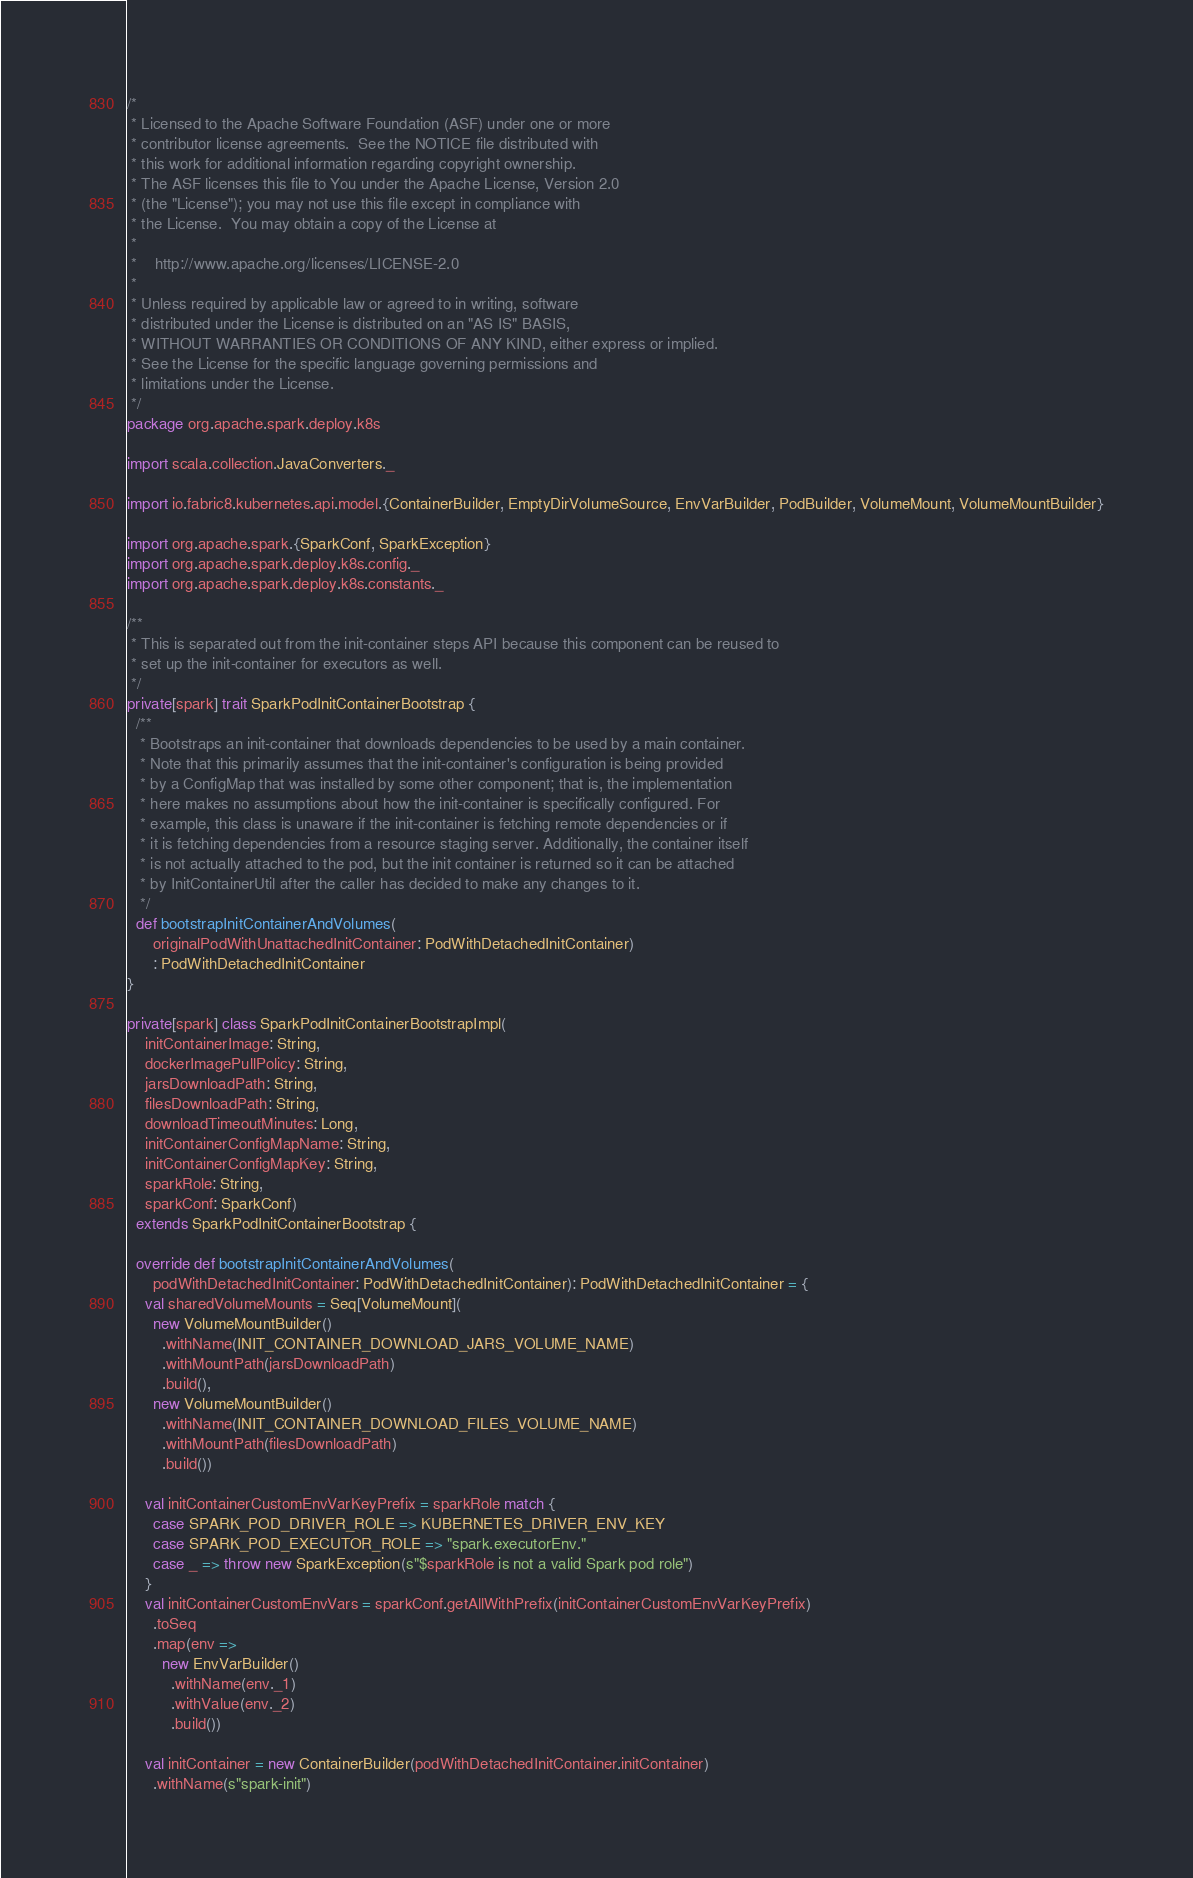Convert code to text. <code><loc_0><loc_0><loc_500><loc_500><_Scala_>/*
 * Licensed to the Apache Software Foundation (ASF) under one or more
 * contributor license agreements.  See the NOTICE file distributed with
 * this work for additional information regarding copyright ownership.
 * The ASF licenses this file to You under the Apache License, Version 2.0
 * (the "License"); you may not use this file except in compliance with
 * the License.  You may obtain a copy of the License at
 *
 *    http://www.apache.org/licenses/LICENSE-2.0
 *
 * Unless required by applicable law or agreed to in writing, software
 * distributed under the License is distributed on an "AS IS" BASIS,
 * WITHOUT WARRANTIES OR CONDITIONS OF ANY KIND, either express or implied.
 * See the License for the specific language governing permissions and
 * limitations under the License.
 */
package org.apache.spark.deploy.k8s

import scala.collection.JavaConverters._

import io.fabric8.kubernetes.api.model.{ContainerBuilder, EmptyDirVolumeSource, EnvVarBuilder, PodBuilder, VolumeMount, VolumeMountBuilder}

import org.apache.spark.{SparkConf, SparkException}
import org.apache.spark.deploy.k8s.config._
import org.apache.spark.deploy.k8s.constants._

/**
 * This is separated out from the init-container steps API because this component can be reused to
 * set up the init-container for executors as well.
 */
private[spark] trait SparkPodInitContainerBootstrap {
  /**
   * Bootstraps an init-container that downloads dependencies to be used by a main container.
   * Note that this primarily assumes that the init-container's configuration is being provided
   * by a ConfigMap that was installed by some other component; that is, the implementation
   * here makes no assumptions about how the init-container is specifically configured. For
   * example, this class is unaware if the init-container is fetching remote dependencies or if
   * it is fetching dependencies from a resource staging server. Additionally, the container itself
   * is not actually attached to the pod, but the init container is returned so it can be attached
   * by InitContainerUtil after the caller has decided to make any changes to it.
   */
  def bootstrapInitContainerAndVolumes(
      originalPodWithUnattachedInitContainer: PodWithDetachedInitContainer)
      : PodWithDetachedInitContainer
}

private[spark] class SparkPodInitContainerBootstrapImpl(
    initContainerImage: String,
    dockerImagePullPolicy: String,
    jarsDownloadPath: String,
    filesDownloadPath: String,
    downloadTimeoutMinutes: Long,
    initContainerConfigMapName: String,
    initContainerConfigMapKey: String,
    sparkRole: String,
    sparkConf: SparkConf)
  extends SparkPodInitContainerBootstrap {

  override def bootstrapInitContainerAndVolumes(
      podWithDetachedInitContainer: PodWithDetachedInitContainer): PodWithDetachedInitContainer = {
    val sharedVolumeMounts = Seq[VolumeMount](
      new VolumeMountBuilder()
        .withName(INIT_CONTAINER_DOWNLOAD_JARS_VOLUME_NAME)
        .withMountPath(jarsDownloadPath)
        .build(),
      new VolumeMountBuilder()
        .withName(INIT_CONTAINER_DOWNLOAD_FILES_VOLUME_NAME)
        .withMountPath(filesDownloadPath)
        .build())

    val initContainerCustomEnvVarKeyPrefix = sparkRole match {
      case SPARK_POD_DRIVER_ROLE => KUBERNETES_DRIVER_ENV_KEY
      case SPARK_POD_EXECUTOR_ROLE => "spark.executorEnv."
      case _ => throw new SparkException(s"$sparkRole is not a valid Spark pod role")
    }
    val initContainerCustomEnvVars = sparkConf.getAllWithPrefix(initContainerCustomEnvVarKeyPrefix)
      .toSeq
      .map(env =>
        new EnvVarBuilder()
          .withName(env._1)
          .withValue(env._2)
          .build())

    val initContainer = new ContainerBuilder(podWithDetachedInitContainer.initContainer)
      .withName(s"spark-init")</code> 